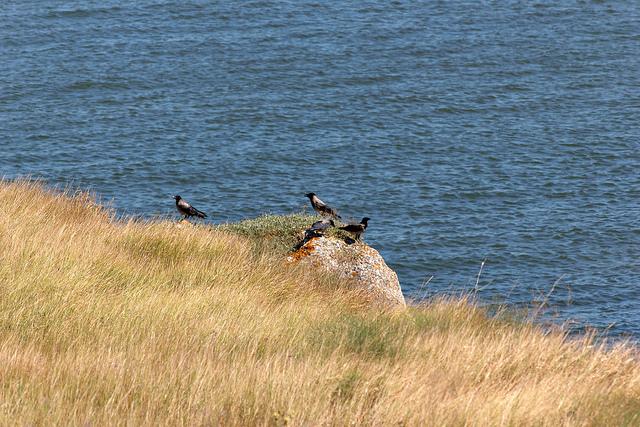What is behind the birds?
Short answer required. Water. Is the water calm?
Answer briefly. Yes. How many birds can be spotted here?
Keep it brief. 4. 